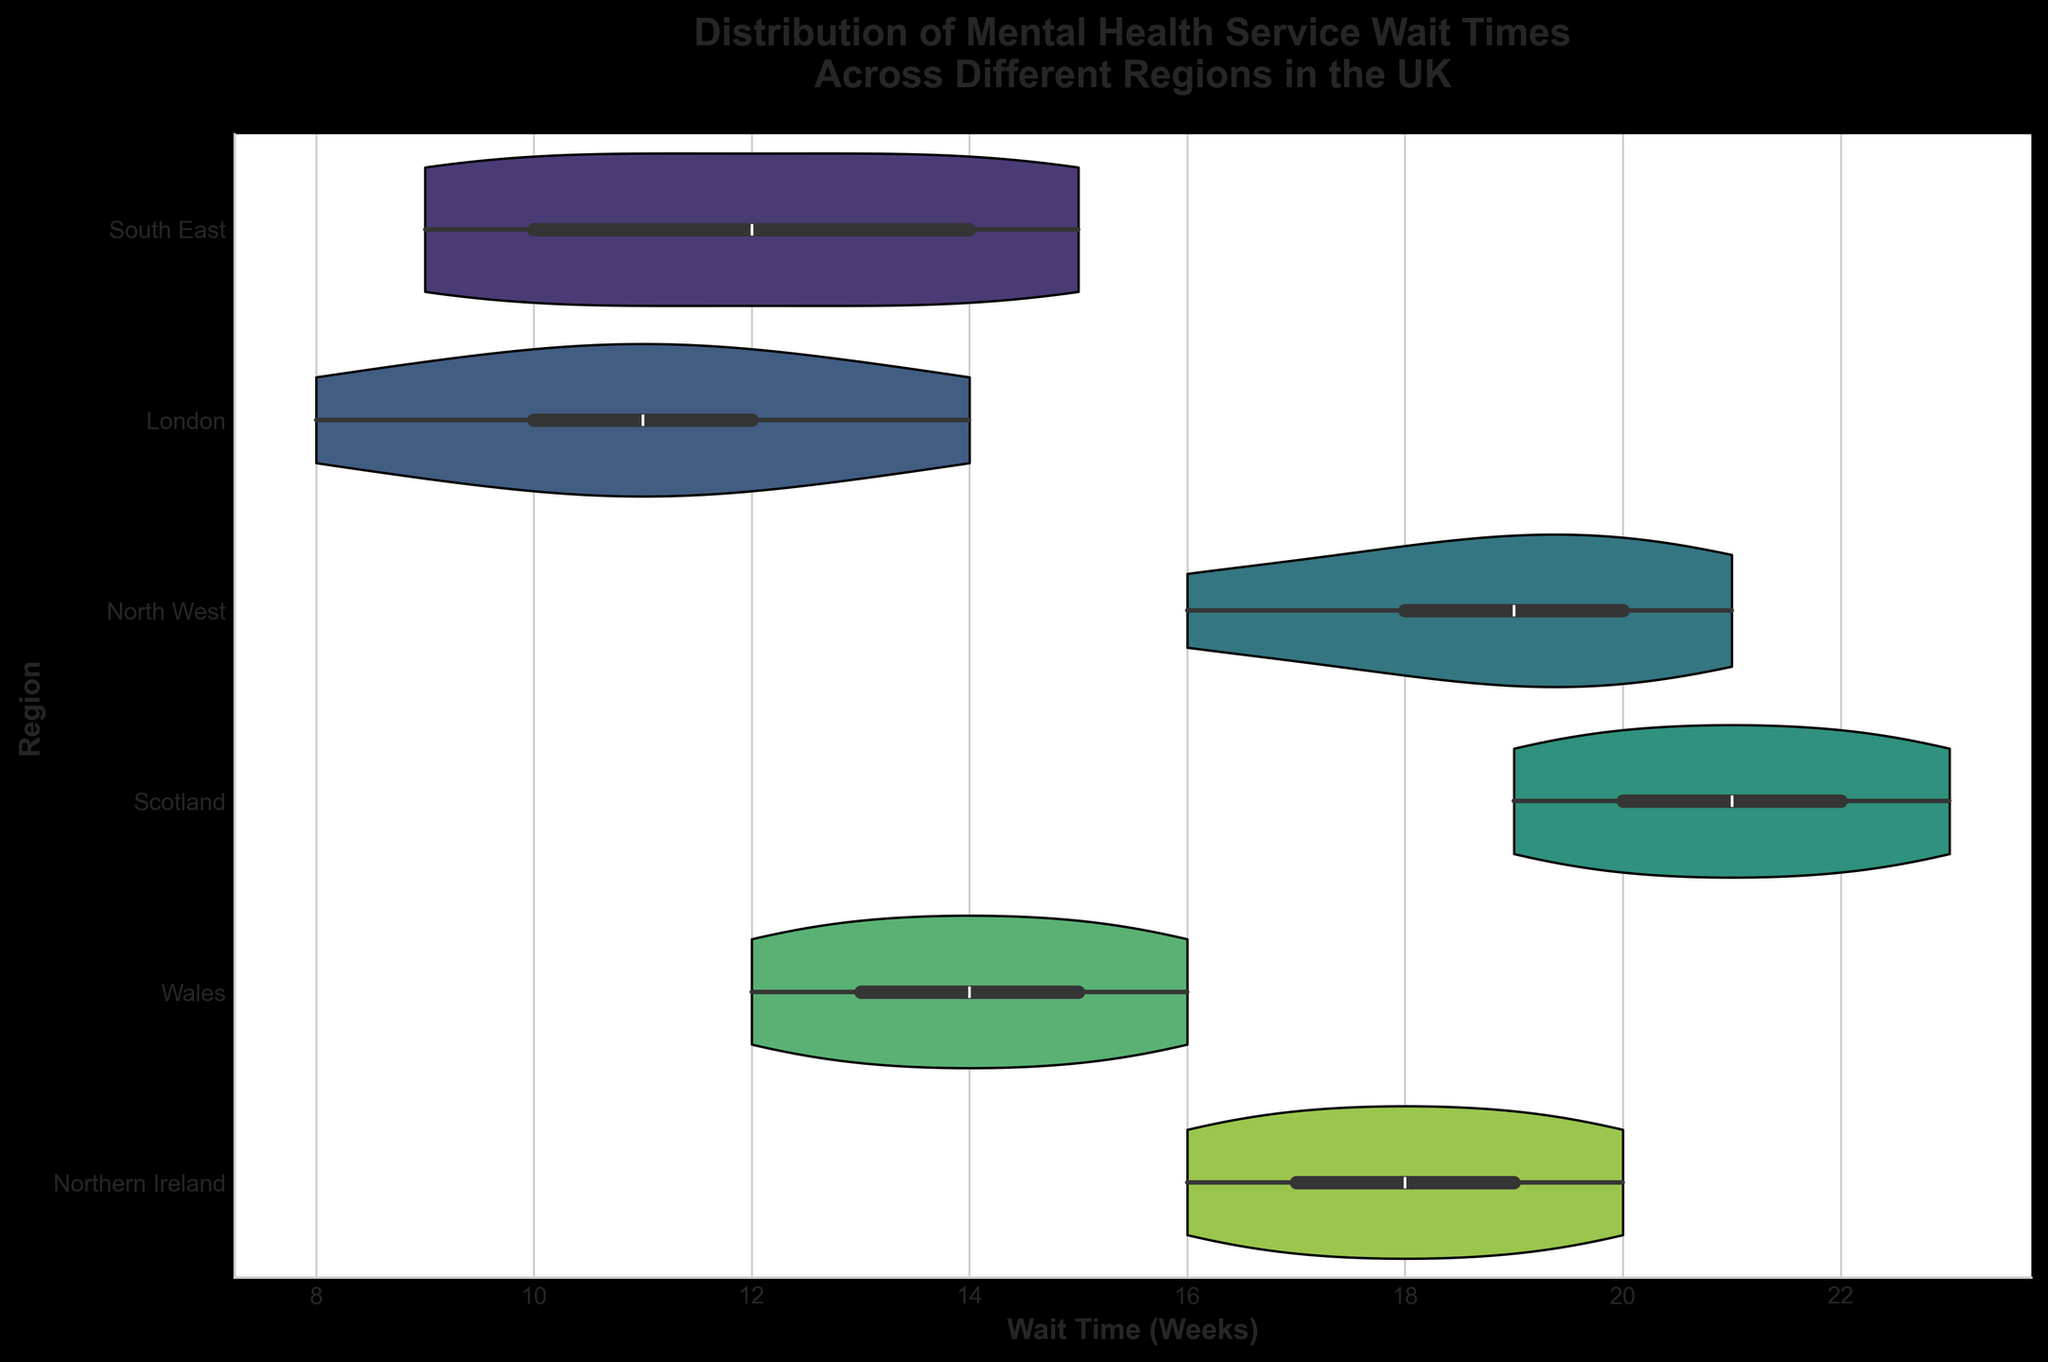What's the title of the chart? The title of the chart is displayed at the top in bold letters.
Answer: Distribution of Mental Health Service Wait Times Across Different Regions in the UK How many different regions are shown in the chart? There are uniquely colored violin plots for each region, which can be counted.
Answer: Six Which region has the widest range of wait times? By comparing the spreads of the violin plots horizontally, the region with the widest range can be identified.
Answer: Scotland What is the median wait time for mental health services in London? The median is usually marked by a line or a dot within the box inside the violin plot.
Answer: 11 weeks Which region has the shortest wait time? The lowest point on the horizontal axis where a violin plot begins will indicate this.
Answer: South East How does the median wait time in Wales compare to Northern Ireland? Compare the median lines or markers in both regions' violin plots.
Answer: Wales has a shorter median wait time than Northern Ireland What is the difference between the longest wait time in the North West and the shortest wait time in the South East? Subtract the shortest wait time observed in the South East violin plot from the longest wait time observed in the North West violin plot.
Answer: 12 weeks Which region has the most tightly clustered wait times? Identify the region with the narrowest distribution in the violin plot.
Answer: South East What is the interquartile range of wait times in Scotland? The interquartile range (IQR) is the distance between the 25th and 75th percentiles. These are often depicted within the box inside the violin plot.
Answer: Around 4 weeks Are there any regions where wait times are evenly distributed? Look for violin plots that are relatively symmetrical and spread out evenly.
Answer: No regions have perfectly even distributions 